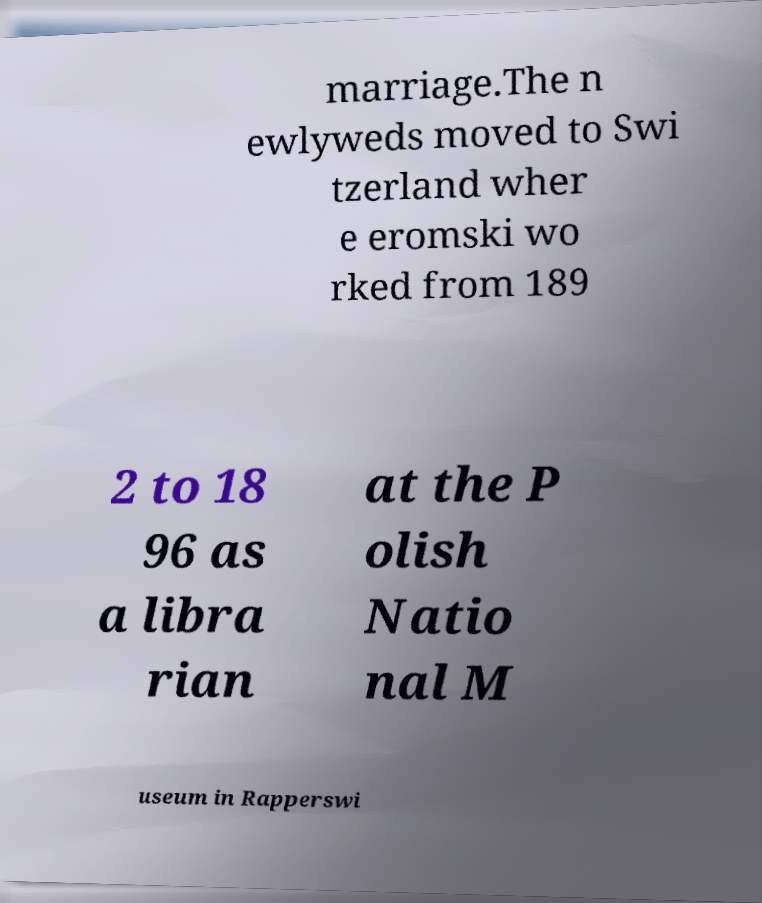Could you assist in decoding the text presented in this image and type it out clearly? marriage.The n ewlyweds moved to Swi tzerland wher e eromski wo rked from 189 2 to 18 96 as a libra rian at the P olish Natio nal M useum in Rapperswi 